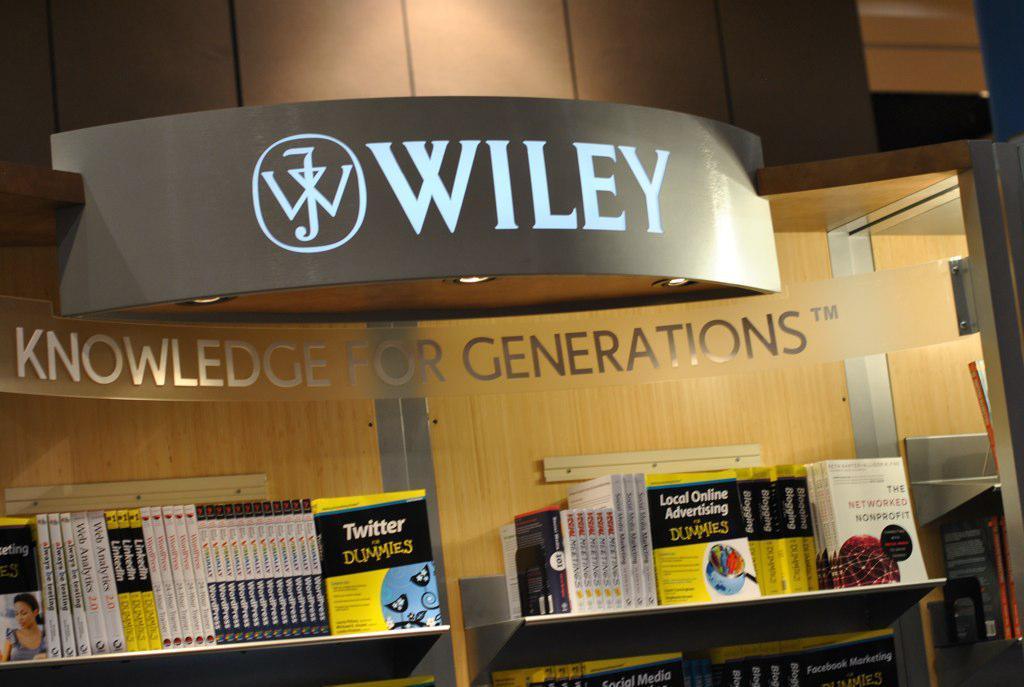Describe this image in one or two sentences. In this image we can see a building and some text written on the building and there are some books in the shelf. 